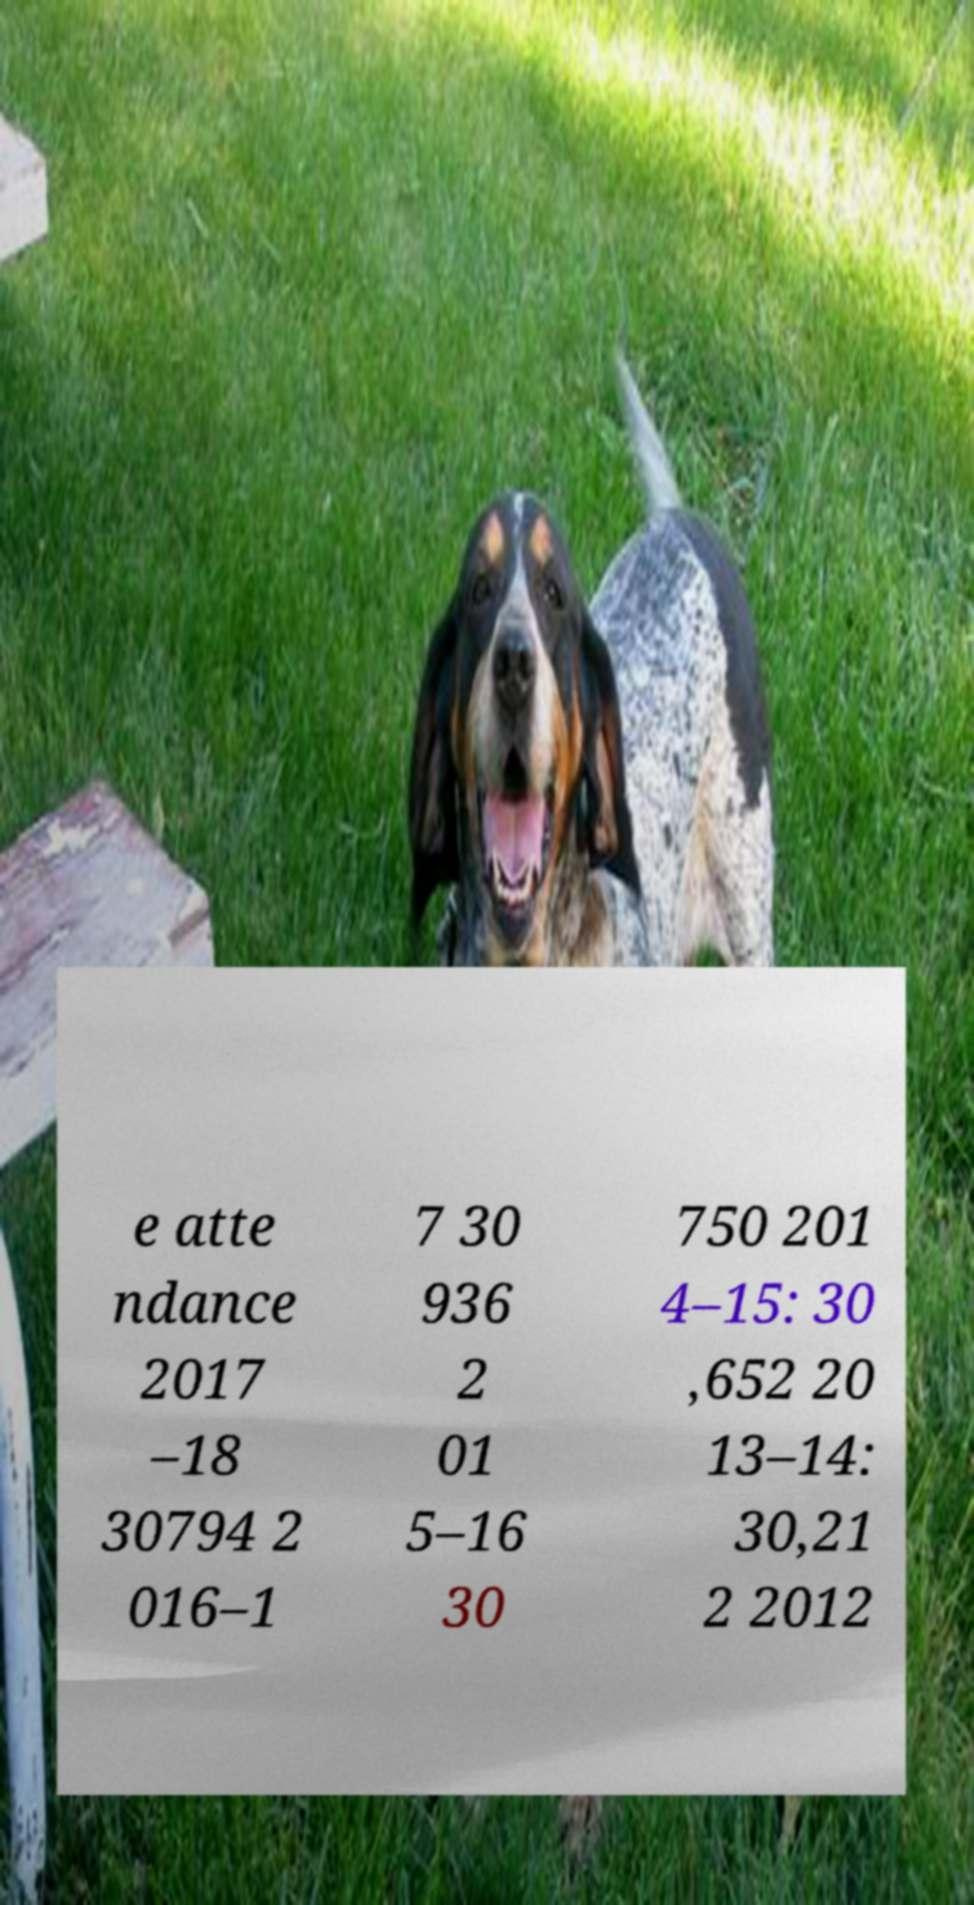Could you extract and type out the text from this image? e atte ndance 2017 –18 30794 2 016–1 7 30 936 2 01 5–16 30 750 201 4–15: 30 ,652 20 13–14: 30,21 2 2012 